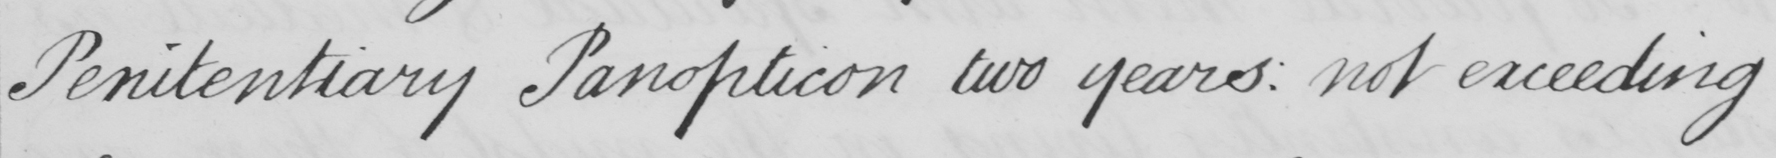Transcribe the text shown in this historical manuscript line. Penitentiary Panopticon two years :  not exceeding 